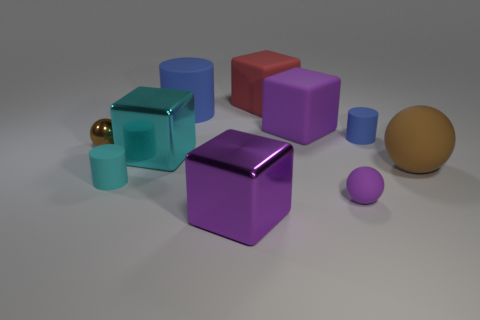Is there any indication of light source direction in the image? Yes, there is an indication of light source direction. The shadows cast on the ground suggest that the light is coming from the upper left side of the image, as indicated by the angles and length of the shadows. 